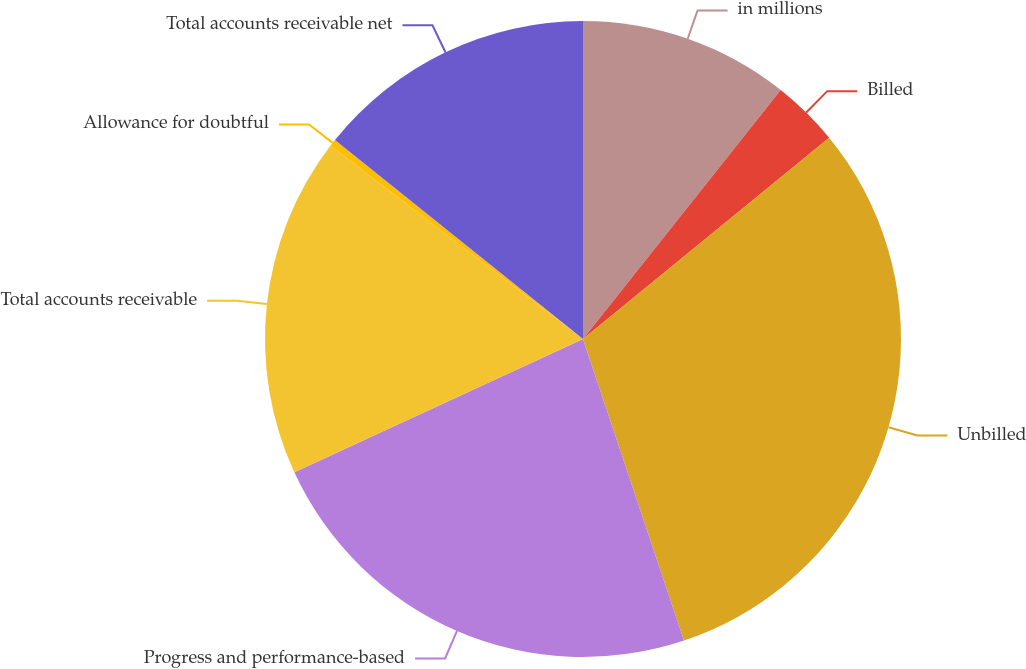<chart> <loc_0><loc_0><loc_500><loc_500><pie_chart><fcel>in millions<fcel>Billed<fcel>Unbilled<fcel>Progress and performance-based<fcel>Total accounts receivable<fcel>Allowance for doubtful<fcel>Total accounts receivable net<nl><fcel>10.68%<fcel>3.41%<fcel>30.77%<fcel>23.26%<fcel>17.28%<fcel>0.37%<fcel>14.24%<nl></chart> 